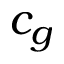<formula> <loc_0><loc_0><loc_500><loc_500>c _ { g }</formula> 